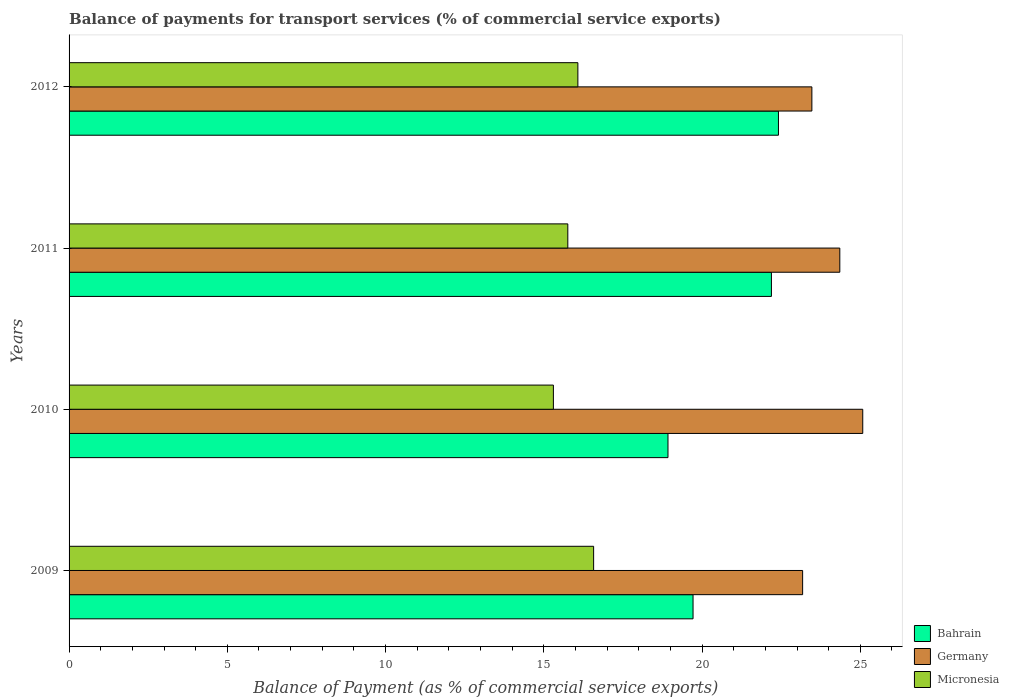How many groups of bars are there?
Keep it short and to the point. 4. Are the number of bars per tick equal to the number of legend labels?
Provide a short and direct response. Yes. Are the number of bars on each tick of the Y-axis equal?
Make the answer very short. Yes. How many bars are there on the 1st tick from the top?
Keep it short and to the point. 3. How many bars are there on the 4th tick from the bottom?
Provide a short and direct response. 3. What is the balance of payments for transport services in Germany in 2012?
Your answer should be very brief. 23.47. Across all years, what is the maximum balance of payments for transport services in Bahrain?
Make the answer very short. 22.41. Across all years, what is the minimum balance of payments for transport services in Micronesia?
Offer a very short reply. 15.3. In which year was the balance of payments for transport services in Germany maximum?
Offer a terse response. 2010. What is the total balance of payments for transport services in Germany in the graph?
Give a very brief answer. 96.08. What is the difference between the balance of payments for transport services in Germany in 2010 and that in 2012?
Keep it short and to the point. 1.61. What is the difference between the balance of payments for transport services in Germany in 2009 and the balance of payments for transport services in Bahrain in 2011?
Give a very brief answer. 0.99. What is the average balance of payments for transport services in Micronesia per year?
Offer a very short reply. 15.93. In the year 2012, what is the difference between the balance of payments for transport services in Bahrain and balance of payments for transport services in Micronesia?
Your response must be concise. 6.34. What is the ratio of the balance of payments for transport services in Bahrain in 2010 to that in 2012?
Provide a short and direct response. 0.84. What is the difference between the highest and the second highest balance of payments for transport services in Bahrain?
Ensure brevity in your answer.  0.22. What is the difference between the highest and the lowest balance of payments for transport services in Germany?
Ensure brevity in your answer.  1.9. Is the sum of the balance of payments for transport services in Bahrain in 2009 and 2011 greater than the maximum balance of payments for transport services in Germany across all years?
Provide a succinct answer. Yes. What does the 3rd bar from the top in 2010 represents?
Make the answer very short. Bahrain. What does the 1st bar from the bottom in 2009 represents?
Offer a very short reply. Bahrain. Is it the case that in every year, the sum of the balance of payments for transport services in Bahrain and balance of payments for transport services in Germany is greater than the balance of payments for transport services in Micronesia?
Offer a terse response. Yes. How many bars are there?
Offer a terse response. 12. Are the values on the major ticks of X-axis written in scientific E-notation?
Your answer should be very brief. No. Does the graph contain any zero values?
Give a very brief answer. No. Does the graph contain grids?
Your response must be concise. No. Where does the legend appear in the graph?
Your response must be concise. Bottom right. How many legend labels are there?
Offer a terse response. 3. How are the legend labels stacked?
Offer a terse response. Vertical. What is the title of the graph?
Ensure brevity in your answer.  Balance of payments for transport services (% of commercial service exports). Does "Bahrain" appear as one of the legend labels in the graph?
Ensure brevity in your answer.  Yes. What is the label or title of the X-axis?
Ensure brevity in your answer.  Balance of Payment (as % of commercial service exports). What is the label or title of the Y-axis?
Your response must be concise. Years. What is the Balance of Payment (as % of commercial service exports) of Bahrain in 2009?
Give a very brief answer. 19.72. What is the Balance of Payment (as % of commercial service exports) of Germany in 2009?
Keep it short and to the point. 23.18. What is the Balance of Payment (as % of commercial service exports) of Micronesia in 2009?
Provide a short and direct response. 16.57. What is the Balance of Payment (as % of commercial service exports) of Bahrain in 2010?
Give a very brief answer. 18.92. What is the Balance of Payment (as % of commercial service exports) of Germany in 2010?
Make the answer very short. 25.08. What is the Balance of Payment (as % of commercial service exports) in Micronesia in 2010?
Your answer should be compact. 15.3. What is the Balance of Payment (as % of commercial service exports) in Bahrain in 2011?
Your response must be concise. 22.19. What is the Balance of Payment (as % of commercial service exports) in Germany in 2011?
Your response must be concise. 24.35. What is the Balance of Payment (as % of commercial service exports) of Micronesia in 2011?
Your answer should be very brief. 15.76. What is the Balance of Payment (as % of commercial service exports) of Bahrain in 2012?
Your response must be concise. 22.41. What is the Balance of Payment (as % of commercial service exports) in Germany in 2012?
Offer a very short reply. 23.47. What is the Balance of Payment (as % of commercial service exports) of Micronesia in 2012?
Ensure brevity in your answer.  16.08. Across all years, what is the maximum Balance of Payment (as % of commercial service exports) in Bahrain?
Give a very brief answer. 22.41. Across all years, what is the maximum Balance of Payment (as % of commercial service exports) in Germany?
Your answer should be compact. 25.08. Across all years, what is the maximum Balance of Payment (as % of commercial service exports) in Micronesia?
Provide a succinct answer. 16.57. Across all years, what is the minimum Balance of Payment (as % of commercial service exports) in Bahrain?
Offer a terse response. 18.92. Across all years, what is the minimum Balance of Payment (as % of commercial service exports) in Germany?
Your answer should be very brief. 23.18. Across all years, what is the minimum Balance of Payment (as % of commercial service exports) of Micronesia?
Offer a terse response. 15.3. What is the total Balance of Payment (as % of commercial service exports) in Bahrain in the graph?
Ensure brevity in your answer.  83.24. What is the total Balance of Payment (as % of commercial service exports) of Germany in the graph?
Provide a short and direct response. 96.08. What is the total Balance of Payment (as % of commercial service exports) of Micronesia in the graph?
Make the answer very short. 63.71. What is the difference between the Balance of Payment (as % of commercial service exports) of Bahrain in 2009 and that in 2010?
Keep it short and to the point. 0.79. What is the difference between the Balance of Payment (as % of commercial service exports) in Germany in 2009 and that in 2010?
Provide a short and direct response. -1.9. What is the difference between the Balance of Payment (as % of commercial service exports) in Micronesia in 2009 and that in 2010?
Make the answer very short. 1.27. What is the difference between the Balance of Payment (as % of commercial service exports) of Bahrain in 2009 and that in 2011?
Offer a terse response. -2.48. What is the difference between the Balance of Payment (as % of commercial service exports) in Germany in 2009 and that in 2011?
Offer a terse response. -1.17. What is the difference between the Balance of Payment (as % of commercial service exports) of Micronesia in 2009 and that in 2011?
Offer a very short reply. 0.82. What is the difference between the Balance of Payment (as % of commercial service exports) of Bahrain in 2009 and that in 2012?
Give a very brief answer. -2.7. What is the difference between the Balance of Payment (as % of commercial service exports) in Germany in 2009 and that in 2012?
Provide a succinct answer. -0.29. What is the difference between the Balance of Payment (as % of commercial service exports) of Micronesia in 2009 and that in 2012?
Your answer should be compact. 0.5. What is the difference between the Balance of Payment (as % of commercial service exports) of Bahrain in 2010 and that in 2011?
Provide a succinct answer. -3.27. What is the difference between the Balance of Payment (as % of commercial service exports) in Germany in 2010 and that in 2011?
Offer a terse response. 0.72. What is the difference between the Balance of Payment (as % of commercial service exports) of Micronesia in 2010 and that in 2011?
Offer a very short reply. -0.46. What is the difference between the Balance of Payment (as % of commercial service exports) of Bahrain in 2010 and that in 2012?
Keep it short and to the point. -3.49. What is the difference between the Balance of Payment (as % of commercial service exports) in Germany in 2010 and that in 2012?
Provide a succinct answer. 1.61. What is the difference between the Balance of Payment (as % of commercial service exports) of Micronesia in 2010 and that in 2012?
Provide a short and direct response. -0.77. What is the difference between the Balance of Payment (as % of commercial service exports) of Bahrain in 2011 and that in 2012?
Provide a short and direct response. -0.22. What is the difference between the Balance of Payment (as % of commercial service exports) of Germany in 2011 and that in 2012?
Your answer should be very brief. 0.88. What is the difference between the Balance of Payment (as % of commercial service exports) in Micronesia in 2011 and that in 2012?
Keep it short and to the point. -0.32. What is the difference between the Balance of Payment (as % of commercial service exports) of Bahrain in 2009 and the Balance of Payment (as % of commercial service exports) of Germany in 2010?
Make the answer very short. -5.36. What is the difference between the Balance of Payment (as % of commercial service exports) in Bahrain in 2009 and the Balance of Payment (as % of commercial service exports) in Micronesia in 2010?
Your answer should be compact. 4.41. What is the difference between the Balance of Payment (as % of commercial service exports) in Germany in 2009 and the Balance of Payment (as % of commercial service exports) in Micronesia in 2010?
Your answer should be very brief. 7.88. What is the difference between the Balance of Payment (as % of commercial service exports) in Bahrain in 2009 and the Balance of Payment (as % of commercial service exports) in Germany in 2011?
Make the answer very short. -4.64. What is the difference between the Balance of Payment (as % of commercial service exports) in Bahrain in 2009 and the Balance of Payment (as % of commercial service exports) in Micronesia in 2011?
Provide a short and direct response. 3.96. What is the difference between the Balance of Payment (as % of commercial service exports) in Germany in 2009 and the Balance of Payment (as % of commercial service exports) in Micronesia in 2011?
Your response must be concise. 7.42. What is the difference between the Balance of Payment (as % of commercial service exports) in Bahrain in 2009 and the Balance of Payment (as % of commercial service exports) in Germany in 2012?
Provide a short and direct response. -3.75. What is the difference between the Balance of Payment (as % of commercial service exports) of Bahrain in 2009 and the Balance of Payment (as % of commercial service exports) of Micronesia in 2012?
Your answer should be compact. 3.64. What is the difference between the Balance of Payment (as % of commercial service exports) of Germany in 2009 and the Balance of Payment (as % of commercial service exports) of Micronesia in 2012?
Keep it short and to the point. 7.1. What is the difference between the Balance of Payment (as % of commercial service exports) in Bahrain in 2010 and the Balance of Payment (as % of commercial service exports) in Germany in 2011?
Your answer should be very brief. -5.43. What is the difference between the Balance of Payment (as % of commercial service exports) in Bahrain in 2010 and the Balance of Payment (as % of commercial service exports) in Micronesia in 2011?
Offer a very short reply. 3.16. What is the difference between the Balance of Payment (as % of commercial service exports) in Germany in 2010 and the Balance of Payment (as % of commercial service exports) in Micronesia in 2011?
Offer a terse response. 9.32. What is the difference between the Balance of Payment (as % of commercial service exports) of Bahrain in 2010 and the Balance of Payment (as % of commercial service exports) of Germany in 2012?
Ensure brevity in your answer.  -4.55. What is the difference between the Balance of Payment (as % of commercial service exports) of Bahrain in 2010 and the Balance of Payment (as % of commercial service exports) of Micronesia in 2012?
Make the answer very short. 2.85. What is the difference between the Balance of Payment (as % of commercial service exports) of Germany in 2010 and the Balance of Payment (as % of commercial service exports) of Micronesia in 2012?
Offer a terse response. 9. What is the difference between the Balance of Payment (as % of commercial service exports) in Bahrain in 2011 and the Balance of Payment (as % of commercial service exports) in Germany in 2012?
Offer a very short reply. -1.28. What is the difference between the Balance of Payment (as % of commercial service exports) of Bahrain in 2011 and the Balance of Payment (as % of commercial service exports) of Micronesia in 2012?
Offer a very short reply. 6.12. What is the difference between the Balance of Payment (as % of commercial service exports) of Germany in 2011 and the Balance of Payment (as % of commercial service exports) of Micronesia in 2012?
Your answer should be very brief. 8.28. What is the average Balance of Payment (as % of commercial service exports) of Bahrain per year?
Your answer should be very brief. 20.81. What is the average Balance of Payment (as % of commercial service exports) of Germany per year?
Your response must be concise. 24.02. What is the average Balance of Payment (as % of commercial service exports) of Micronesia per year?
Keep it short and to the point. 15.93. In the year 2009, what is the difference between the Balance of Payment (as % of commercial service exports) in Bahrain and Balance of Payment (as % of commercial service exports) in Germany?
Provide a short and direct response. -3.46. In the year 2009, what is the difference between the Balance of Payment (as % of commercial service exports) of Bahrain and Balance of Payment (as % of commercial service exports) of Micronesia?
Give a very brief answer. 3.14. In the year 2009, what is the difference between the Balance of Payment (as % of commercial service exports) of Germany and Balance of Payment (as % of commercial service exports) of Micronesia?
Offer a very short reply. 6.6. In the year 2010, what is the difference between the Balance of Payment (as % of commercial service exports) in Bahrain and Balance of Payment (as % of commercial service exports) in Germany?
Offer a terse response. -6.15. In the year 2010, what is the difference between the Balance of Payment (as % of commercial service exports) in Bahrain and Balance of Payment (as % of commercial service exports) in Micronesia?
Your answer should be compact. 3.62. In the year 2010, what is the difference between the Balance of Payment (as % of commercial service exports) in Germany and Balance of Payment (as % of commercial service exports) in Micronesia?
Give a very brief answer. 9.77. In the year 2011, what is the difference between the Balance of Payment (as % of commercial service exports) of Bahrain and Balance of Payment (as % of commercial service exports) of Germany?
Give a very brief answer. -2.16. In the year 2011, what is the difference between the Balance of Payment (as % of commercial service exports) in Bahrain and Balance of Payment (as % of commercial service exports) in Micronesia?
Your response must be concise. 6.43. In the year 2011, what is the difference between the Balance of Payment (as % of commercial service exports) of Germany and Balance of Payment (as % of commercial service exports) of Micronesia?
Ensure brevity in your answer.  8.59. In the year 2012, what is the difference between the Balance of Payment (as % of commercial service exports) of Bahrain and Balance of Payment (as % of commercial service exports) of Germany?
Provide a succinct answer. -1.06. In the year 2012, what is the difference between the Balance of Payment (as % of commercial service exports) in Bahrain and Balance of Payment (as % of commercial service exports) in Micronesia?
Provide a succinct answer. 6.34. In the year 2012, what is the difference between the Balance of Payment (as % of commercial service exports) in Germany and Balance of Payment (as % of commercial service exports) in Micronesia?
Offer a terse response. 7.39. What is the ratio of the Balance of Payment (as % of commercial service exports) in Bahrain in 2009 to that in 2010?
Your answer should be compact. 1.04. What is the ratio of the Balance of Payment (as % of commercial service exports) of Germany in 2009 to that in 2010?
Make the answer very short. 0.92. What is the ratio of the Balance of Payment (as % of commercial service exports) in Micronesia in 2009 to that in 2010?
Your answer should be very brief. 1.08. What is the ratio of the Balance of Payment (as % of commercial service exports) of Bahrain in 2009 to that in 2011?
Your response must be concise. 0.89. What is the ratio of the Balance of Payment (as % of commercial service exports) in Germany in 2009 to that in 2011?
Offer a terse response. 0.95. What is the ratio of the Balance of Payment (as % of commercial service exports) in Micronesia in 2009 to that in 2011?
Provide a succinct answer. 1.05. What is the ratio of the Balance of Payment (as % of commercial service exports) of Bahrain in 2009 to that in 2012?
Your response must be concise. 0.88. What is the ratio of the Balance of Payment (as % of commercial service exports) of Germany in 2009 to that in 2012?
Offer a very short reply. 0.99. What is the ratio of the Balance of Payment (as % of commercial service exports) in Micronesia in 2009 to that in 2012?
Offer a very short reply. 1.03. What is the ratio of the Balance of Payment (as % of commercial service exports) in Bahrain in 2010 to that in 2011?
Offer a terse response. 0.85. What is the ratio of the Balance of Payment (as % of commercial service exports) of Germany in 2010 to that in 2011?
Provide a short and direct response. 1.03. What is the ratio of the Balance of Payment (as % of commercial service exports) of Micronesia in 2010 to that in 2011?
Ensure brevity in your answer.  0.97. What is the ratio of the Balance of Payment (as % of commercial service exports) of Bahrain in 2010 to that in 2012?
Your answer should be compact. 0.84. What is the ratio of the Balance of Payment (as % of commercial service exports) in Germany in 2010 to that in 2012?
Keep it short and to the point. 1.07. What is the ratio of the Balance of Payment (as % of commercial service exports) of Micronesia in 2010 to that in 2012?
Offer a very short reply. 0.95. What is the ratio of the Balance of Payment (as % of commercial service exports) in Germany in 2011 to that in 2012?
Offer a terse response. 1.04. What is the ratio of the Balance of Payment (as % of commercial service exports) in Micronesia in 2011 to that in 2012?
Give a very brief answer. 0.98. What is the difference between the highest and the second highest Balance of Payment (as % of commercial service exports) in Bahrain?
Ensure brevity in your answer.  0.22. What is the difference between the highest and the second highest Balance of Payment (as % of commercial service exports) in Germany?
Keep it short and to the point. 0.72. What is the difference between the highest and the second highest Balance of Payment (as % of commercial service exports) in Micronesia?
Offer a very short reply. 0.5. What is the difference between the highest and the lowest Balance of Payment (as % of commercial service exports) in Bahrain?
Offer a terse response. 3.49. What is the difference between the highest and the lowest Balance of Payment (as % of commercial service exports) of Germany?
Give a very brief answer. 1.9. What is the difference between the highest and the lowest Balance of Payment (as % of commercial service exports) in Micronesia?
Provide a short and direct response. 1.27. 